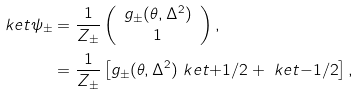Convert formula to latex. <formula><loc_0><loc_0><loc_500><loc_500>\ k e t { \psi _ { \pm } } & = \frac { 1 } { Z _ { \pm } } \left ( \begin{array} { c } g _ { \pm } ( \theta , \Delta ^ { 2 } ) \\ 1 \end{array} \right ) , \\ & = \frac { 1 } { Z _ { \pm } } \left [ g _ { \pm } ( \theta , \Delta ^ { 2 } ) \ k e t { + 1 / 2 } + \ k e t { - 1 / 2 } \right ] ,</formula> 